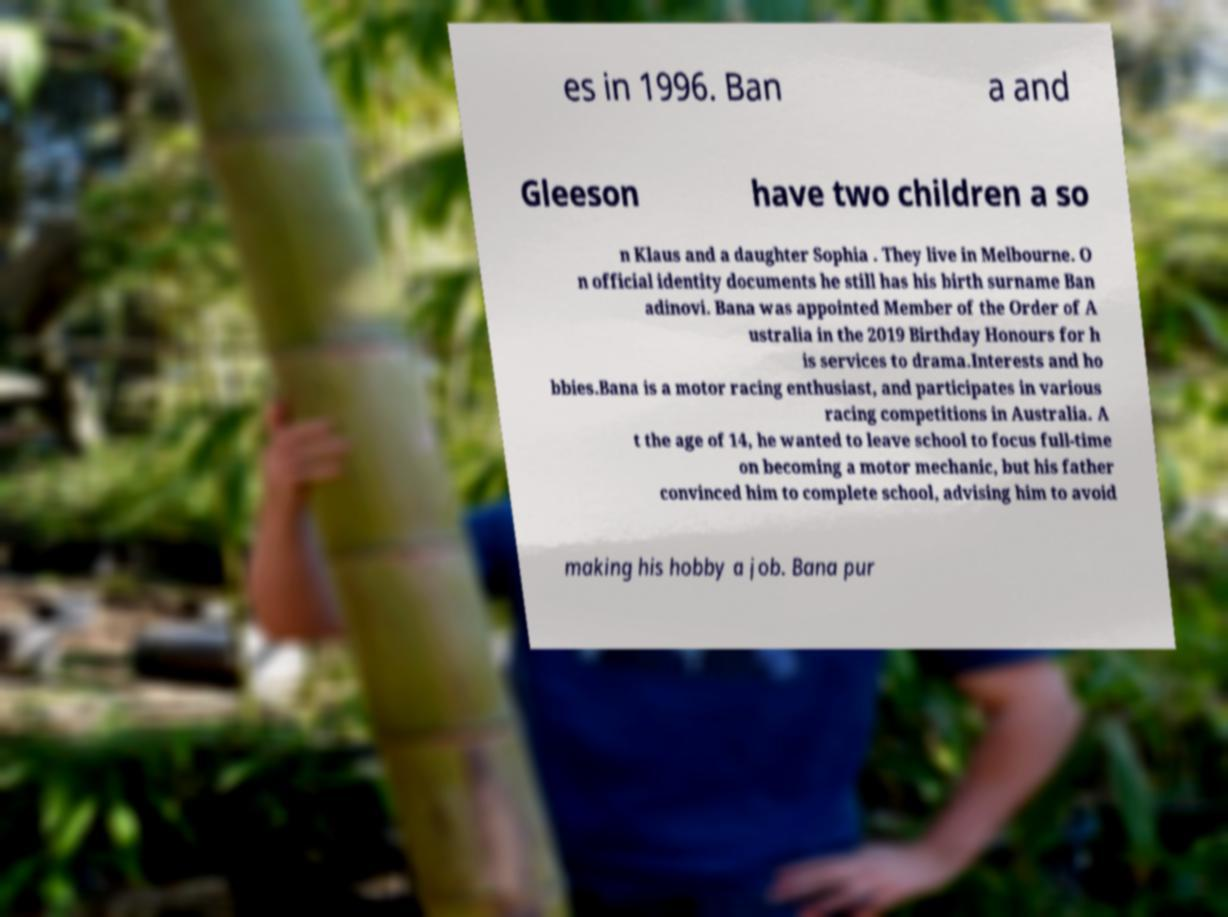For documentation purposes, I need the text within this image transcribed. Could you provide that? es in 1996. Ban a and Gleeson have two children a so n Klaus and a daughter Sophia . They live in Melbourne. O n official identity documents he still has his birth surname Ban adinovi. Bana was appointed Member of the Order of A ustralia in the 2019 Birthday Honours for h is services to drama.Interests and ho bbies.Bana is a motor racing enthusiast, and participates in various racing competitions in Australia. A t the age of 14, he wanted to leave school to focus full-time on becoming a motor mechanic, but his father convinced him to complete school, advising him to avoid making his hobby a job. Bana pur 